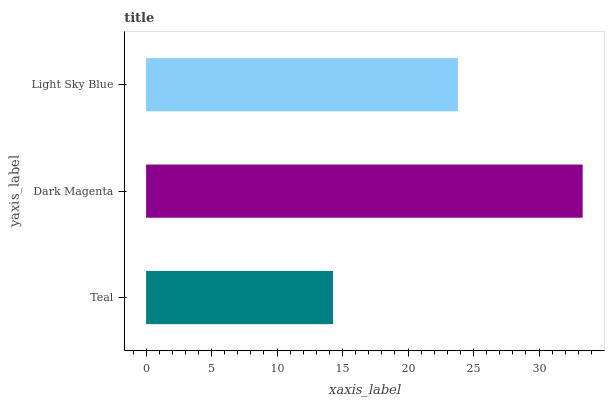Is Teal the minimum?
Answer yes or no. Yes. Is Dark Magenta the maximum?
Answer yes or no. Yes. Is Light Sky Blue the minimum?
Answer yes or no. No. Is Light Sky Blue the maximum?
Answer yes or no. No. Is Dark Magenta greater than Light Sky Blue?
Answer yes or no. Yes. Is Light Sky Blue less than Dark Magenta?
Answer yes or no. Yes. Is Light Sky Blue greater than Dark Magenta?
Answer yes or no. No. Is Dark Magenta less than Light Sky Blue?
Answer yes or no. No. Is Light Sky Blue the high median?
Answer yes or no. Yes. Is Light Sky Blue the low median?
Answer yes or no. Yes. Is Dark Magenta the high median?
Answer yes or no. No. Is Dark Magenta the low median?
Answer yes or no. No. 